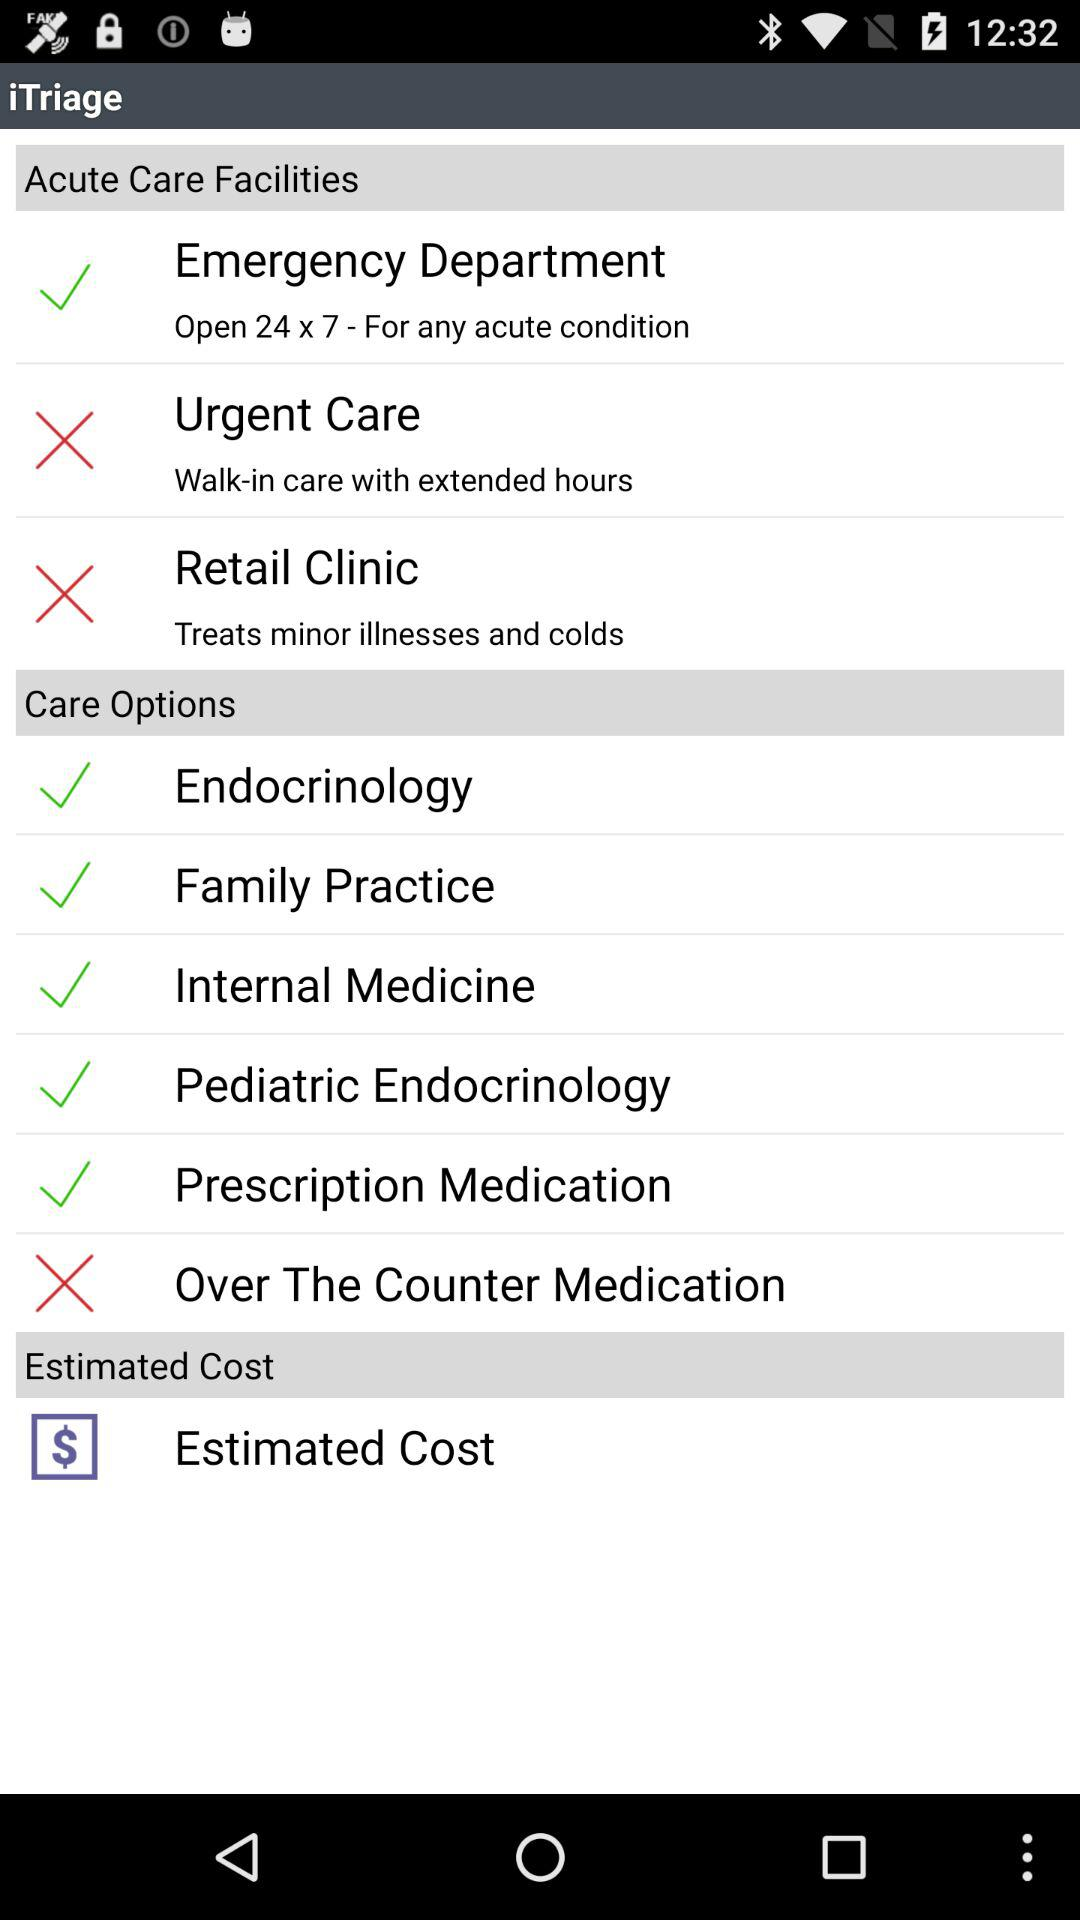How many acute care facilities are there?
Answer the question using a single word or phrase. 3 